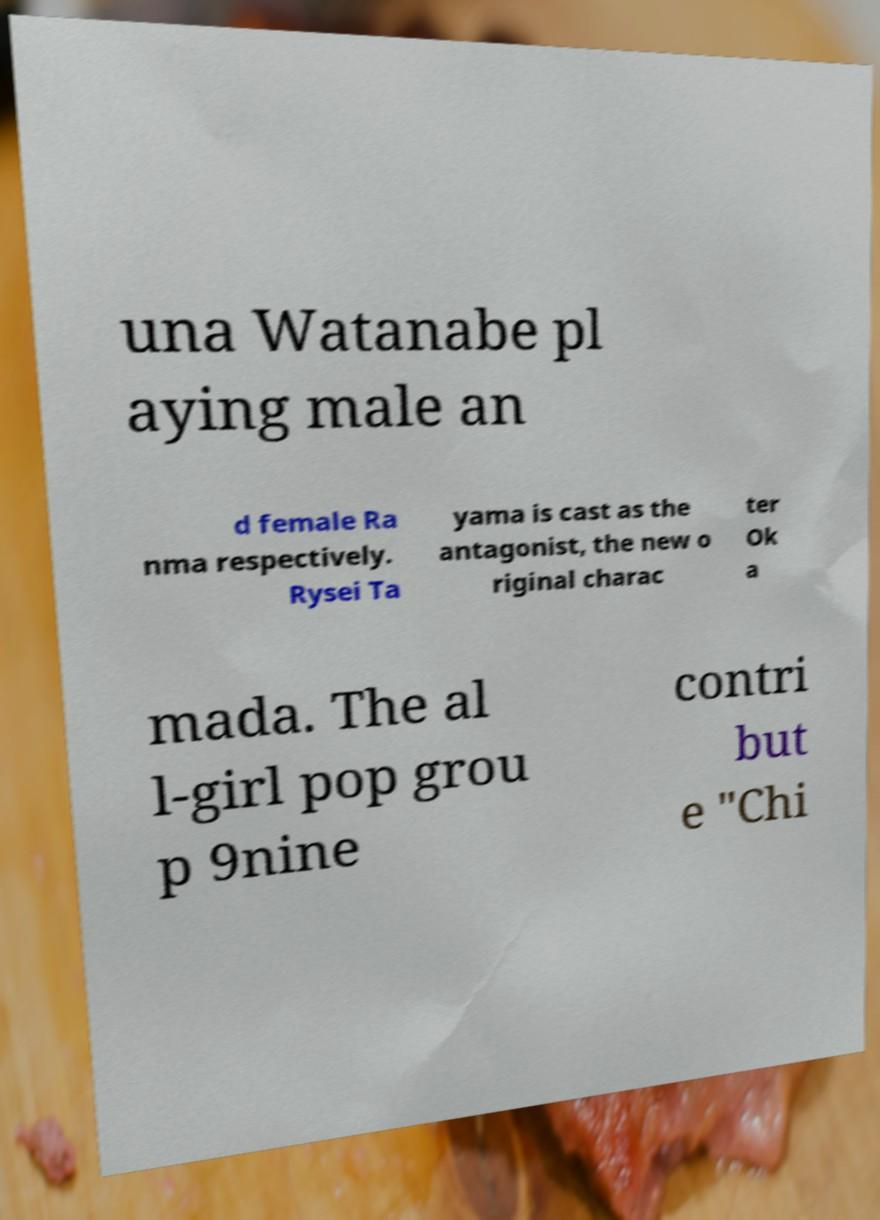Please identify and transcribe the text found in this image. una Watanabe pl aying male an d female Ra nma respectively. Rysei Ta yama is cast as the antagonist, the new o riginal charac ter Ok a mada. The al l-girl pop grou p 9nine contri but e "Chi 